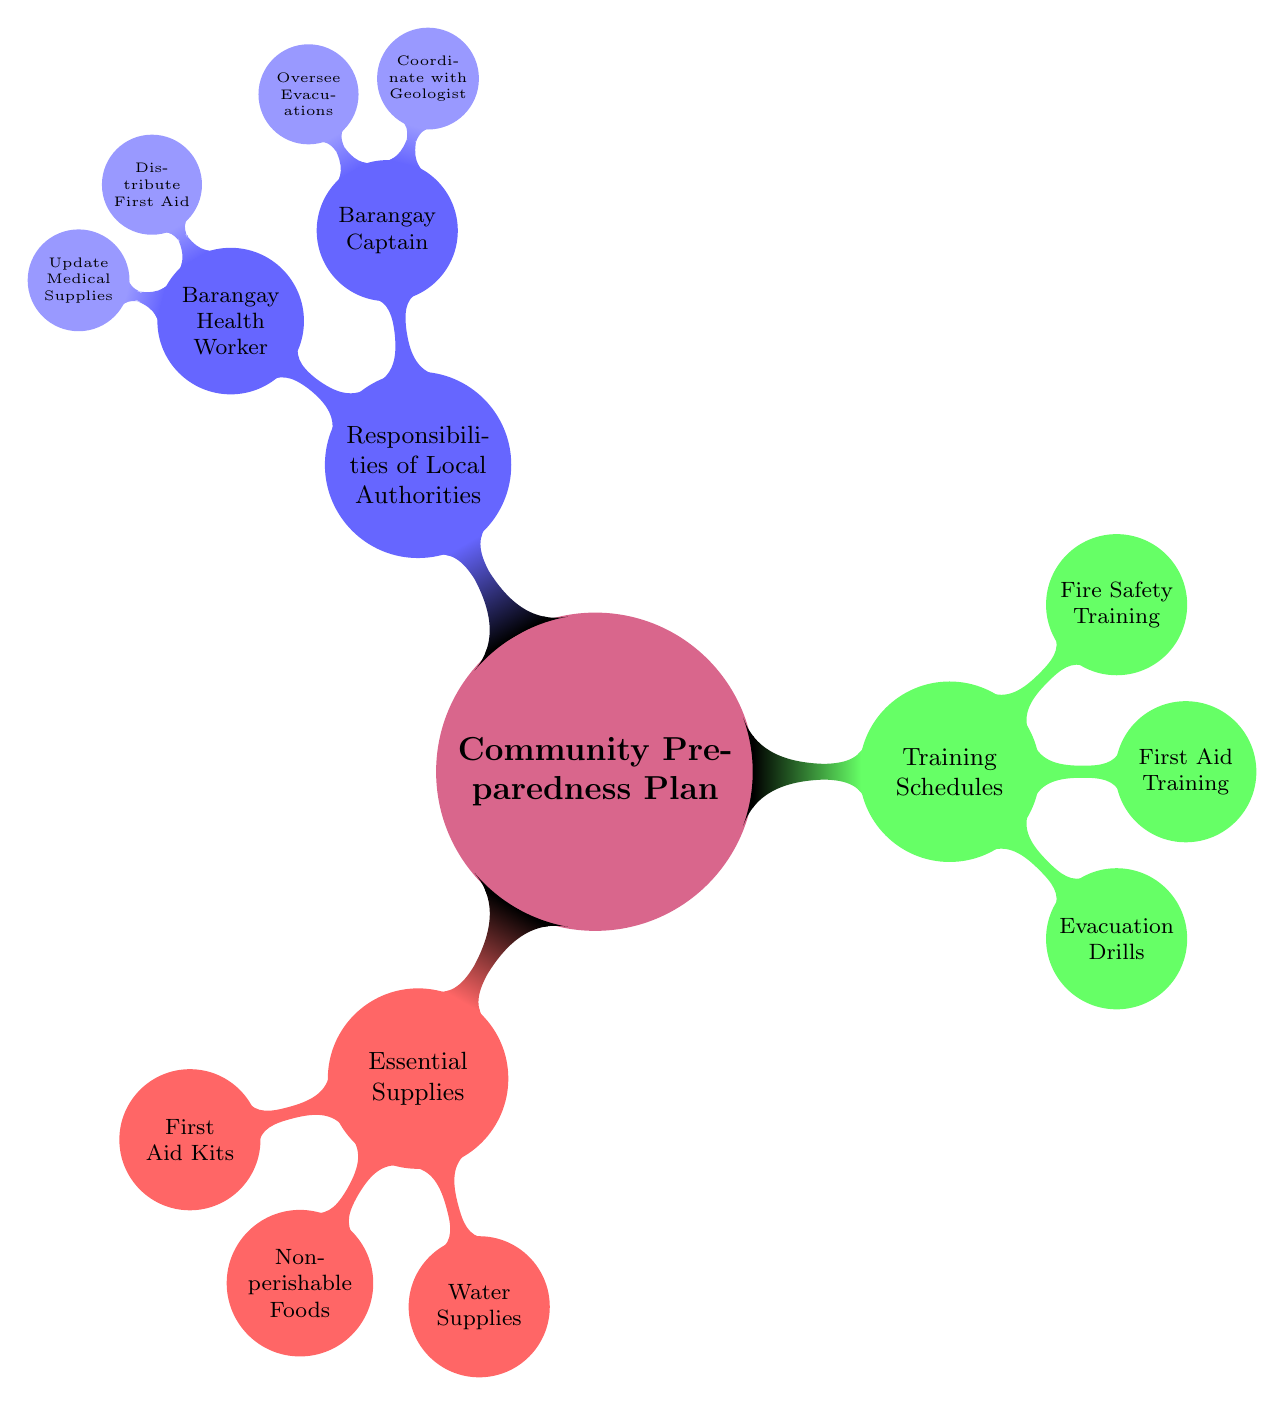What is the main topic of the diagram? The main topic is clearly identified at the center of the diagram, which is labeled as "Community Preparedness Plan."
Answer: Community Preparedness Plan How many essential supplies are listed? By counting the child nodes under the "Essential Supplies," we find three items: First Aid Kits, Non-perishable Foods, and Water Supplies.
Answer: 3 What is one of the training schedules depicted in the diagram? The diagram presents multiple training schedules, one of which is "Evacuation Drills," as indicated under the "Training Schedules" node.
Answer: Evacuation Drills Who is responsible for coordinating with the geologist? The diagram indicates that the "Barangay Captain" is responsible for coordinating with the geologist, as this is a sub-node under the "Responsibilities of Local Authorities."
Answer: Barangay Captain What color represents the "Responsibilities of Local Authorities"? In the diagram, the "Responsibilities of Local Authorities" node is colored blue, differentiating it from other sections.
Answer: Blue What are the two responsibilities of the Barangay Captain listed in the diagram? The diagram shows two responsibilities under the "Barangay Captain": "Coordinate with Geologist" and "Oversee Evacuations," which are detailed as sub-nodes.
Answer: Coordinate with Geologist, Oversee Evacuations How does the number of training schedules compare to the number of essential supplies? There are three "Training Schedules": Evacuation Drills, First Aid Training, and Fire Safety Training. Since there are also three "Essential Supplies," the numbers are equal.
Answer: Equal What is the purpose of the diagram as a whole? The overall purpose is to outline the components of a Community Preparedness Plan, including supplies, training, and responsibilities to ensure community safety during disasters.
Answer: Outline community preparedness components How many nodes are connected to the "Training Schedules"? Under the "Training Schedules," there are three child nodes: Evacuation Drills, First Aid Training, and Fire Safety Training, indicating the number of connections.
Answer: 3 